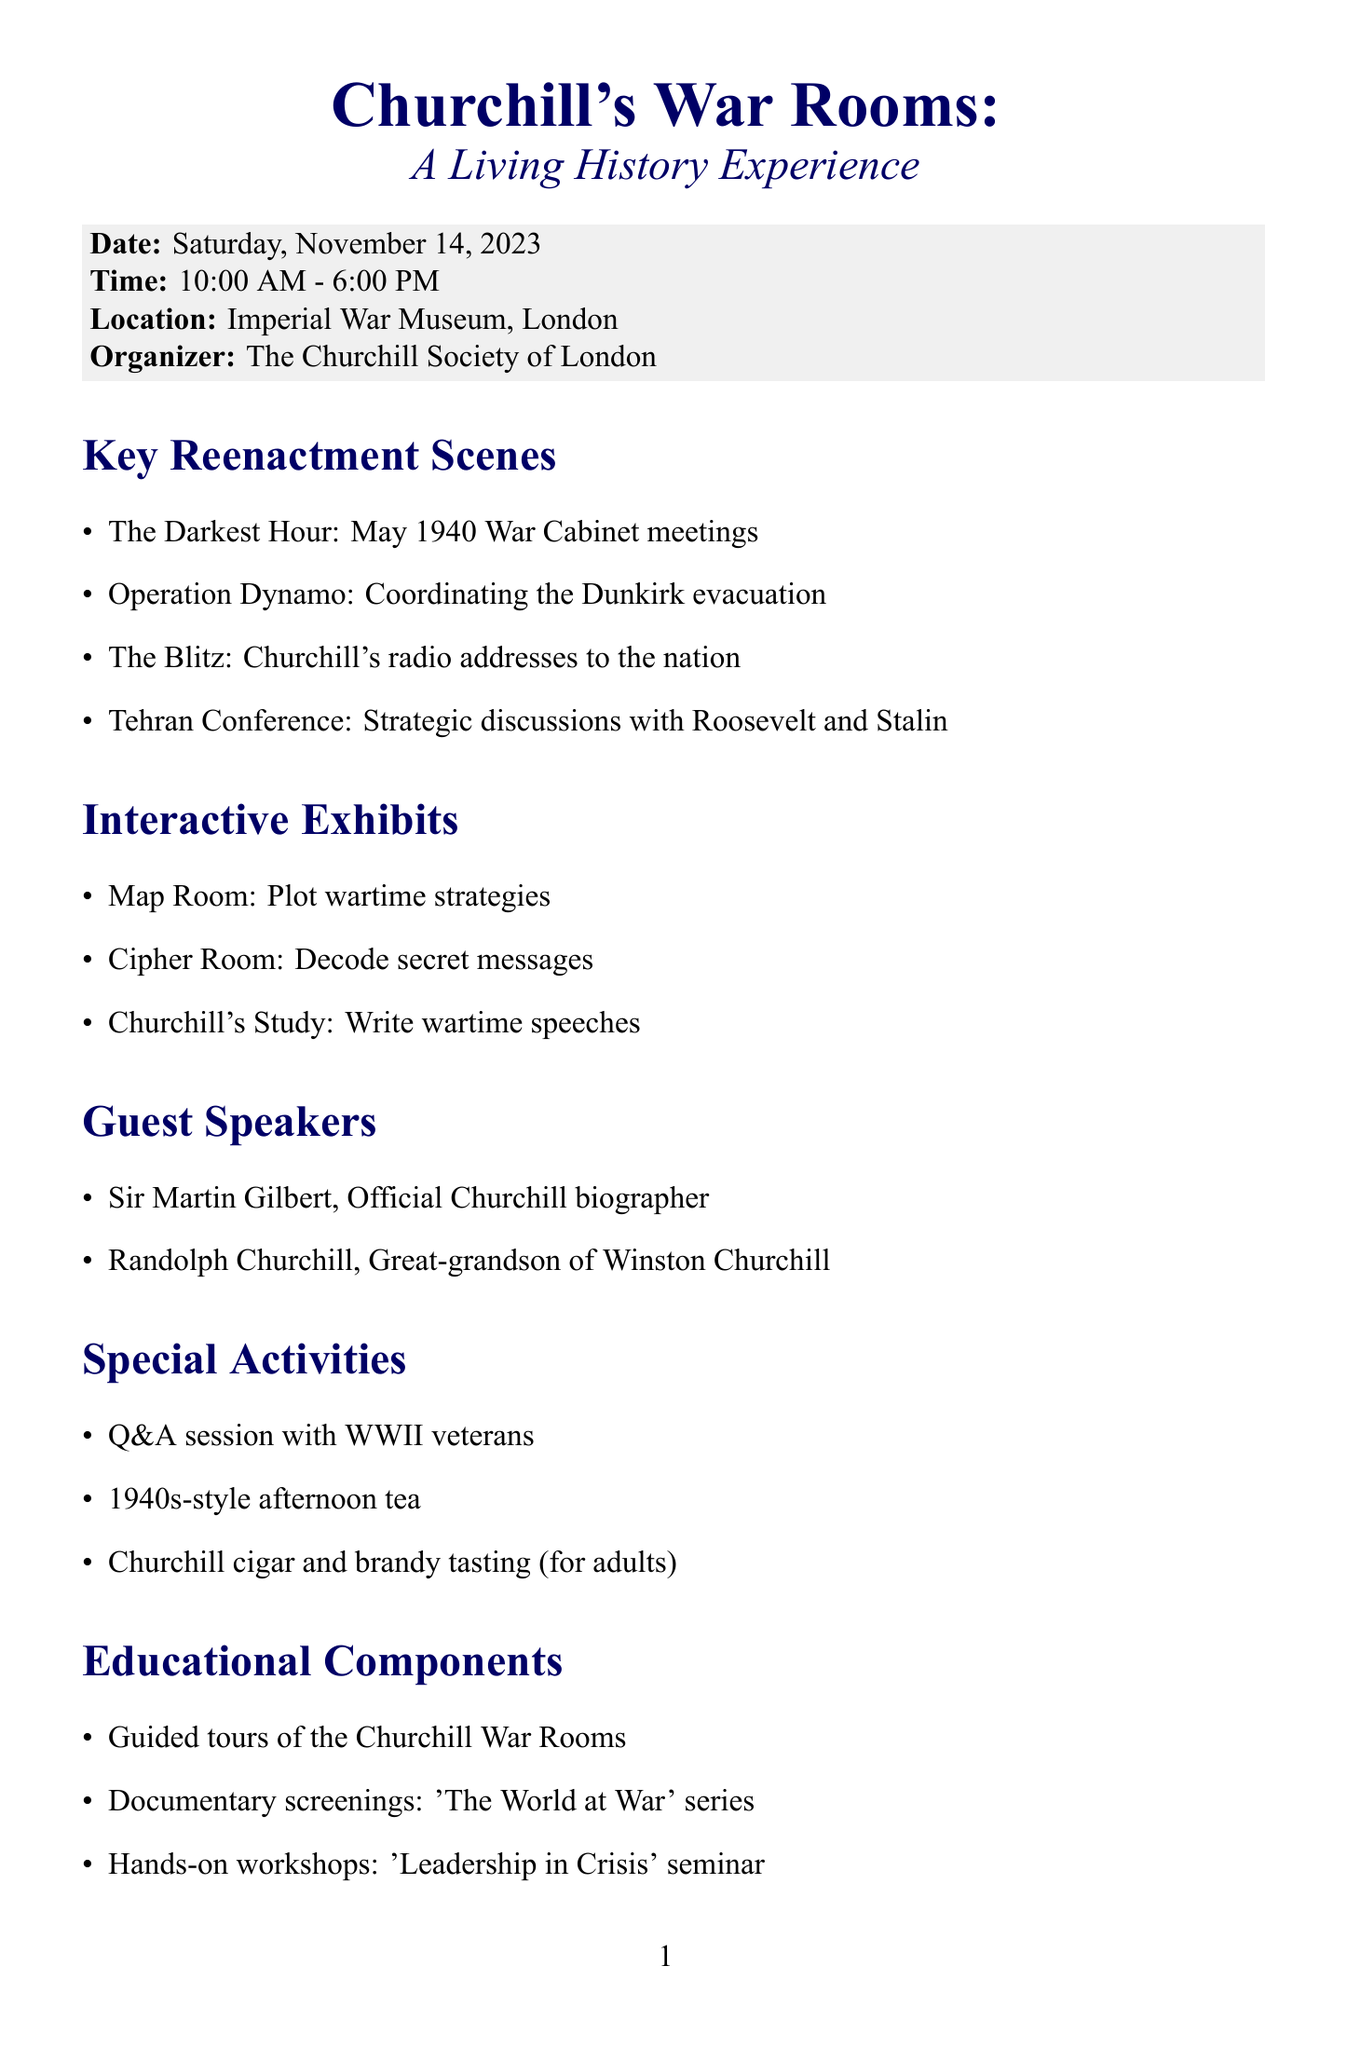What is the event name? The event name is clearly stated at the top of the document.
Answer: Churchill's War Rooms: A Living History Experience What is the date of the event? The date is mentioned right below the event name.
Answer: Saturday, November 14, 2023 Who is the organizer of the event? The organizer is listed in a specific section dedicated to event details.
Answer: The Churchill Society of London What are the ticket prices for students? Ticket prices are detailed in a specific section of the document, with different prices for various groups.
Answer: £15 What is one of the key reenactment scenes? Several key reenactment scenes are listed, highlighting different historical events related to Churchill.
Answer: The Darkest Hour: May 1940 War Cabinet meetings What type of activities are included in the special activities section? The document includes a list of various activities categorized as special activities.
Answer: Q&A session with WWII veterans What is encouraged in terms of dress code? The document specifies the dress code to create an immersive experience, which is stated explicitly.
Answer: 1940s attire encouraged but not required What educational component involves documentary screenings? A specific educational component mentions documentary screenings, which can be found in the relevant section.
Answer: Documentary screenings: 'The World at War' series Who is one of the guest speakers? Guest speakers' names are provided in a dedicated section, showcasing their connection to Churchill.
Answer: Sir Martin Gilbert, Official Churchill biographer 